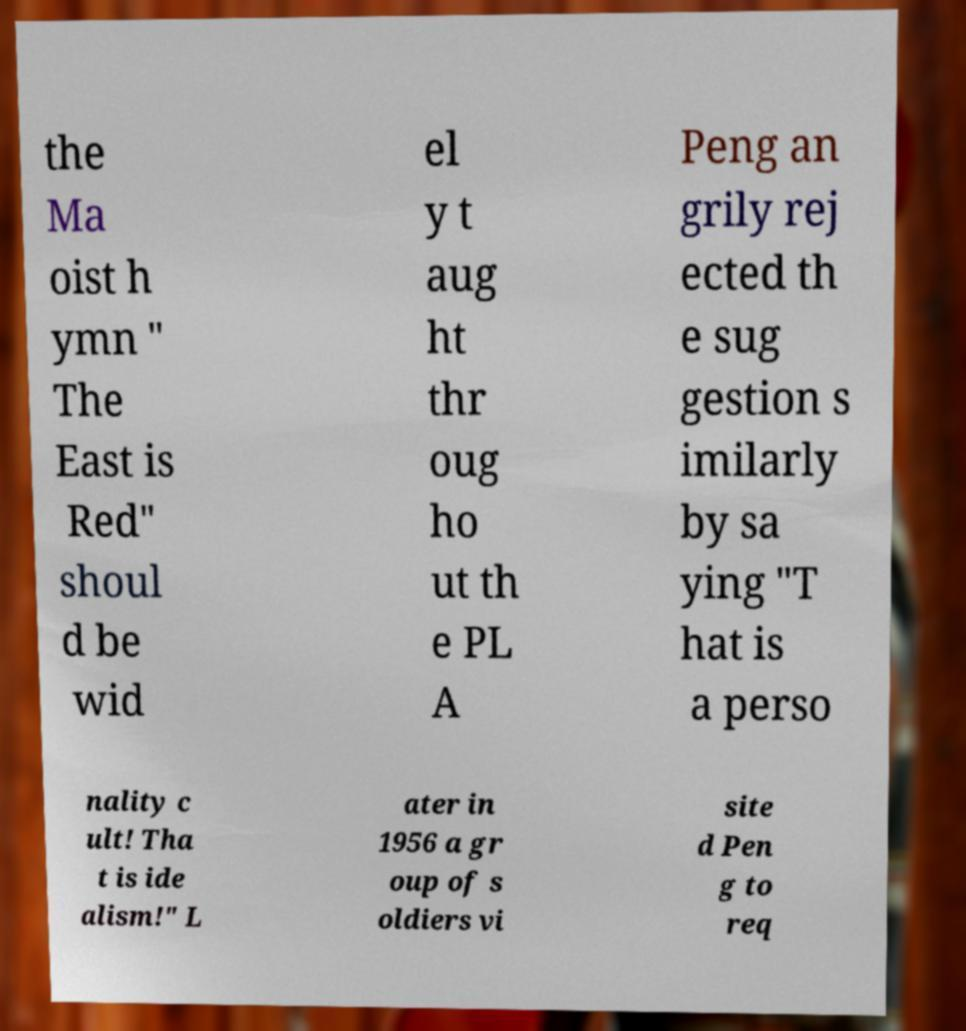I need the written content from this picture converted into text. Can you do that? the Ma oist h ymn " The East is Red" shoul d be wid el y t aug ht thr oug ho ut th e PL A Peng an grily rej ected th e sug gestion s imilarly by sa ying "T hat is a perso nality c ult! Tha t is ide alism!" L ater in 1956 a gr oup of s oldiers vi site d Pen g to req 